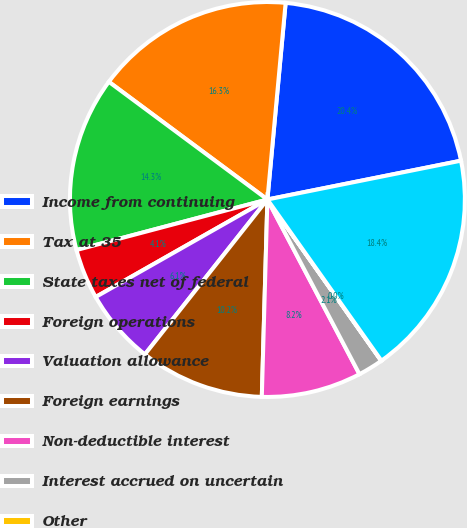Convert chart. <chart><loc_0><loc_0><loc_500><loc_500><pie_chart><fcel>Income from continuing<fcel>Tax at 35<fcel>State taxes net of federal<fcel>Foreign operations<fcel>Valuation allowance<fcel>Foreign earnings<fcel>Non-deductible interest<fcel>Interest accrued on uncertain<fcel>Other<fcel>Income tax expense<nl><fcel>20.38%<fcel>16.31%<fcel>14.28%<fcel>4.1%<fcel>6.13%<fcel>10.2%<fcel>8.17%<fcel>2.06%<fcel>0.02%<fcel>18.35%<nl></chart> 